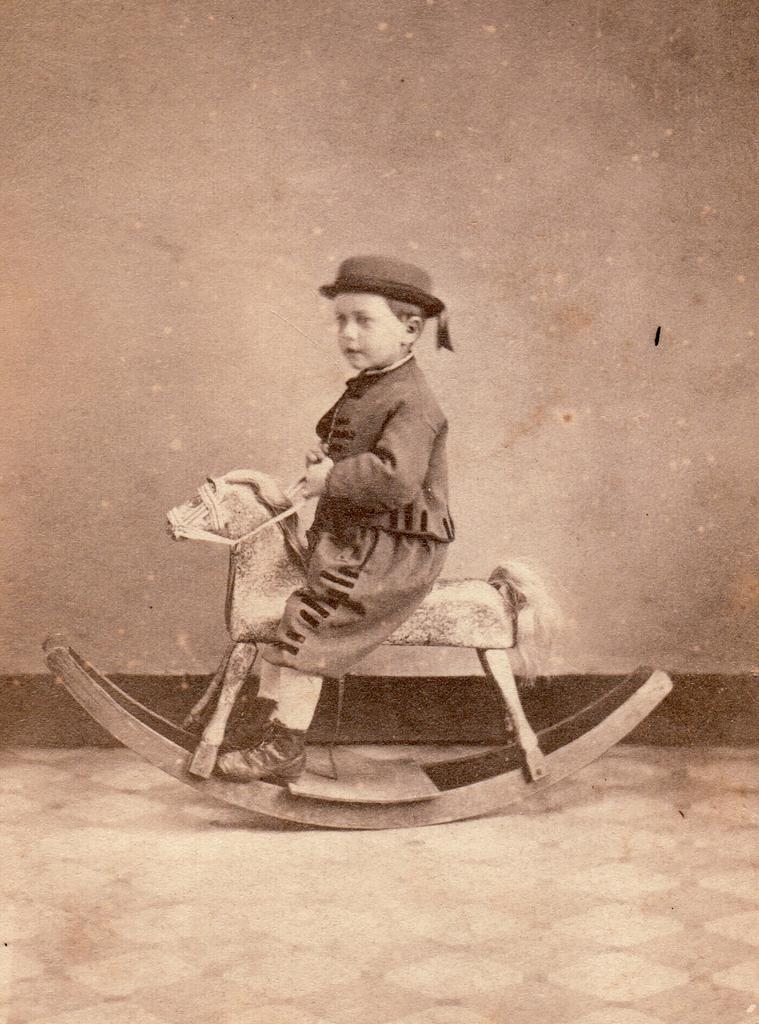Can you describe this image briefly? In this image there is a boy sitting on the toy. Behind him there is a wall. At the bottom of the image there is a floor. 